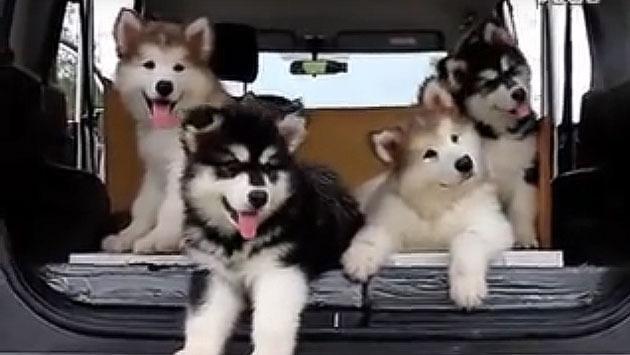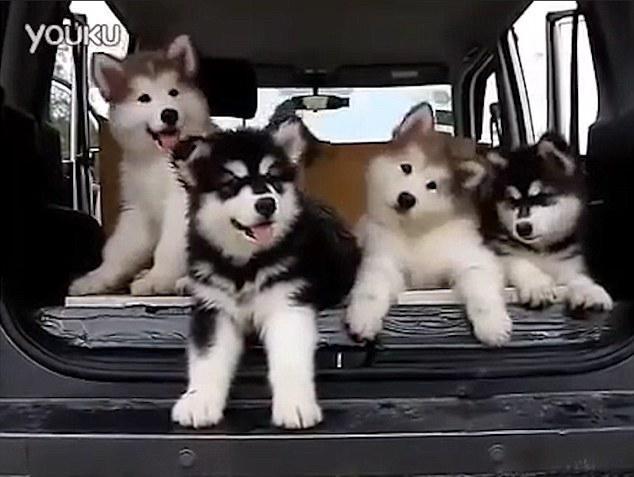The first image is the image on the left, the second image is the image on the right. Examine the images to the left and right. Is the description "Each image includes a black-and-white husky with an open mouth, and at least one image includes a dog reclining on its belly with its front paws extended." accurate? Answer yes or no. Yes. The first image is the image on the left, the second image is the image on the right. Assess this claim about the two images: "A dog is sitting.". Correct or not? Answer yes or no. Yes. 